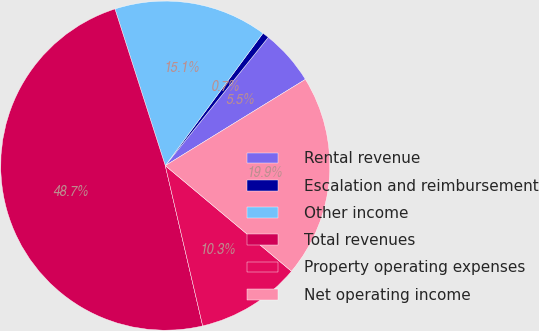Convert chart. <chart><loc_0><loc_0><loc_500><loc_500><pie_chart><fcel>Rental revenue<fcel>Escalation and reimbursement<fcel>Other income<fcel>Total revenues<fcel>Property operating expenses<fcel>Net operating income<nl><fcel>5.45%<fcel>0.65%<fcel>15.06%<fcel>48.7%<fcel>10.26%<fcel>19.87%<nl></chart> 